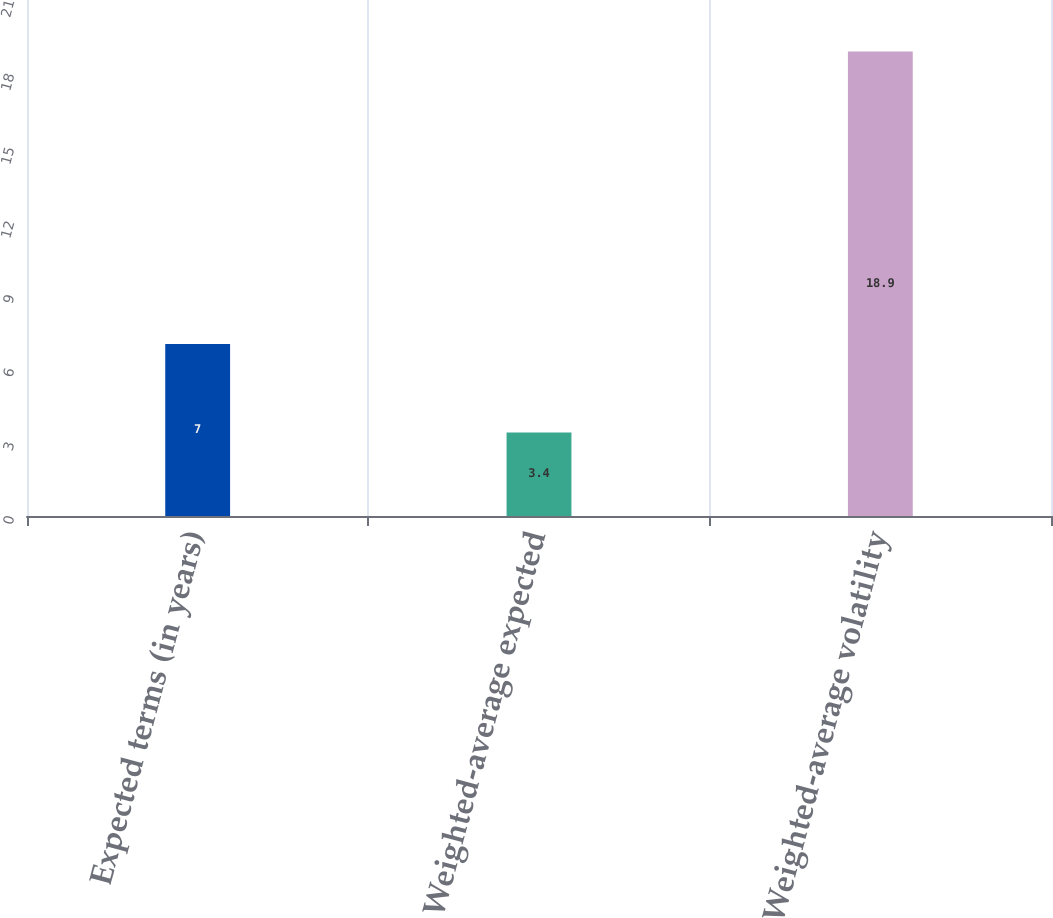<chart> <loc_0><loc_0><loc_500><loc_500><bar_chart><fcel>Expected terms (in years)<fcel>Weighted-average expected<fcel>Weighted-average volatility<nl><fcel>7<fcel>3.4<fcel>18.9<nl></chart> 